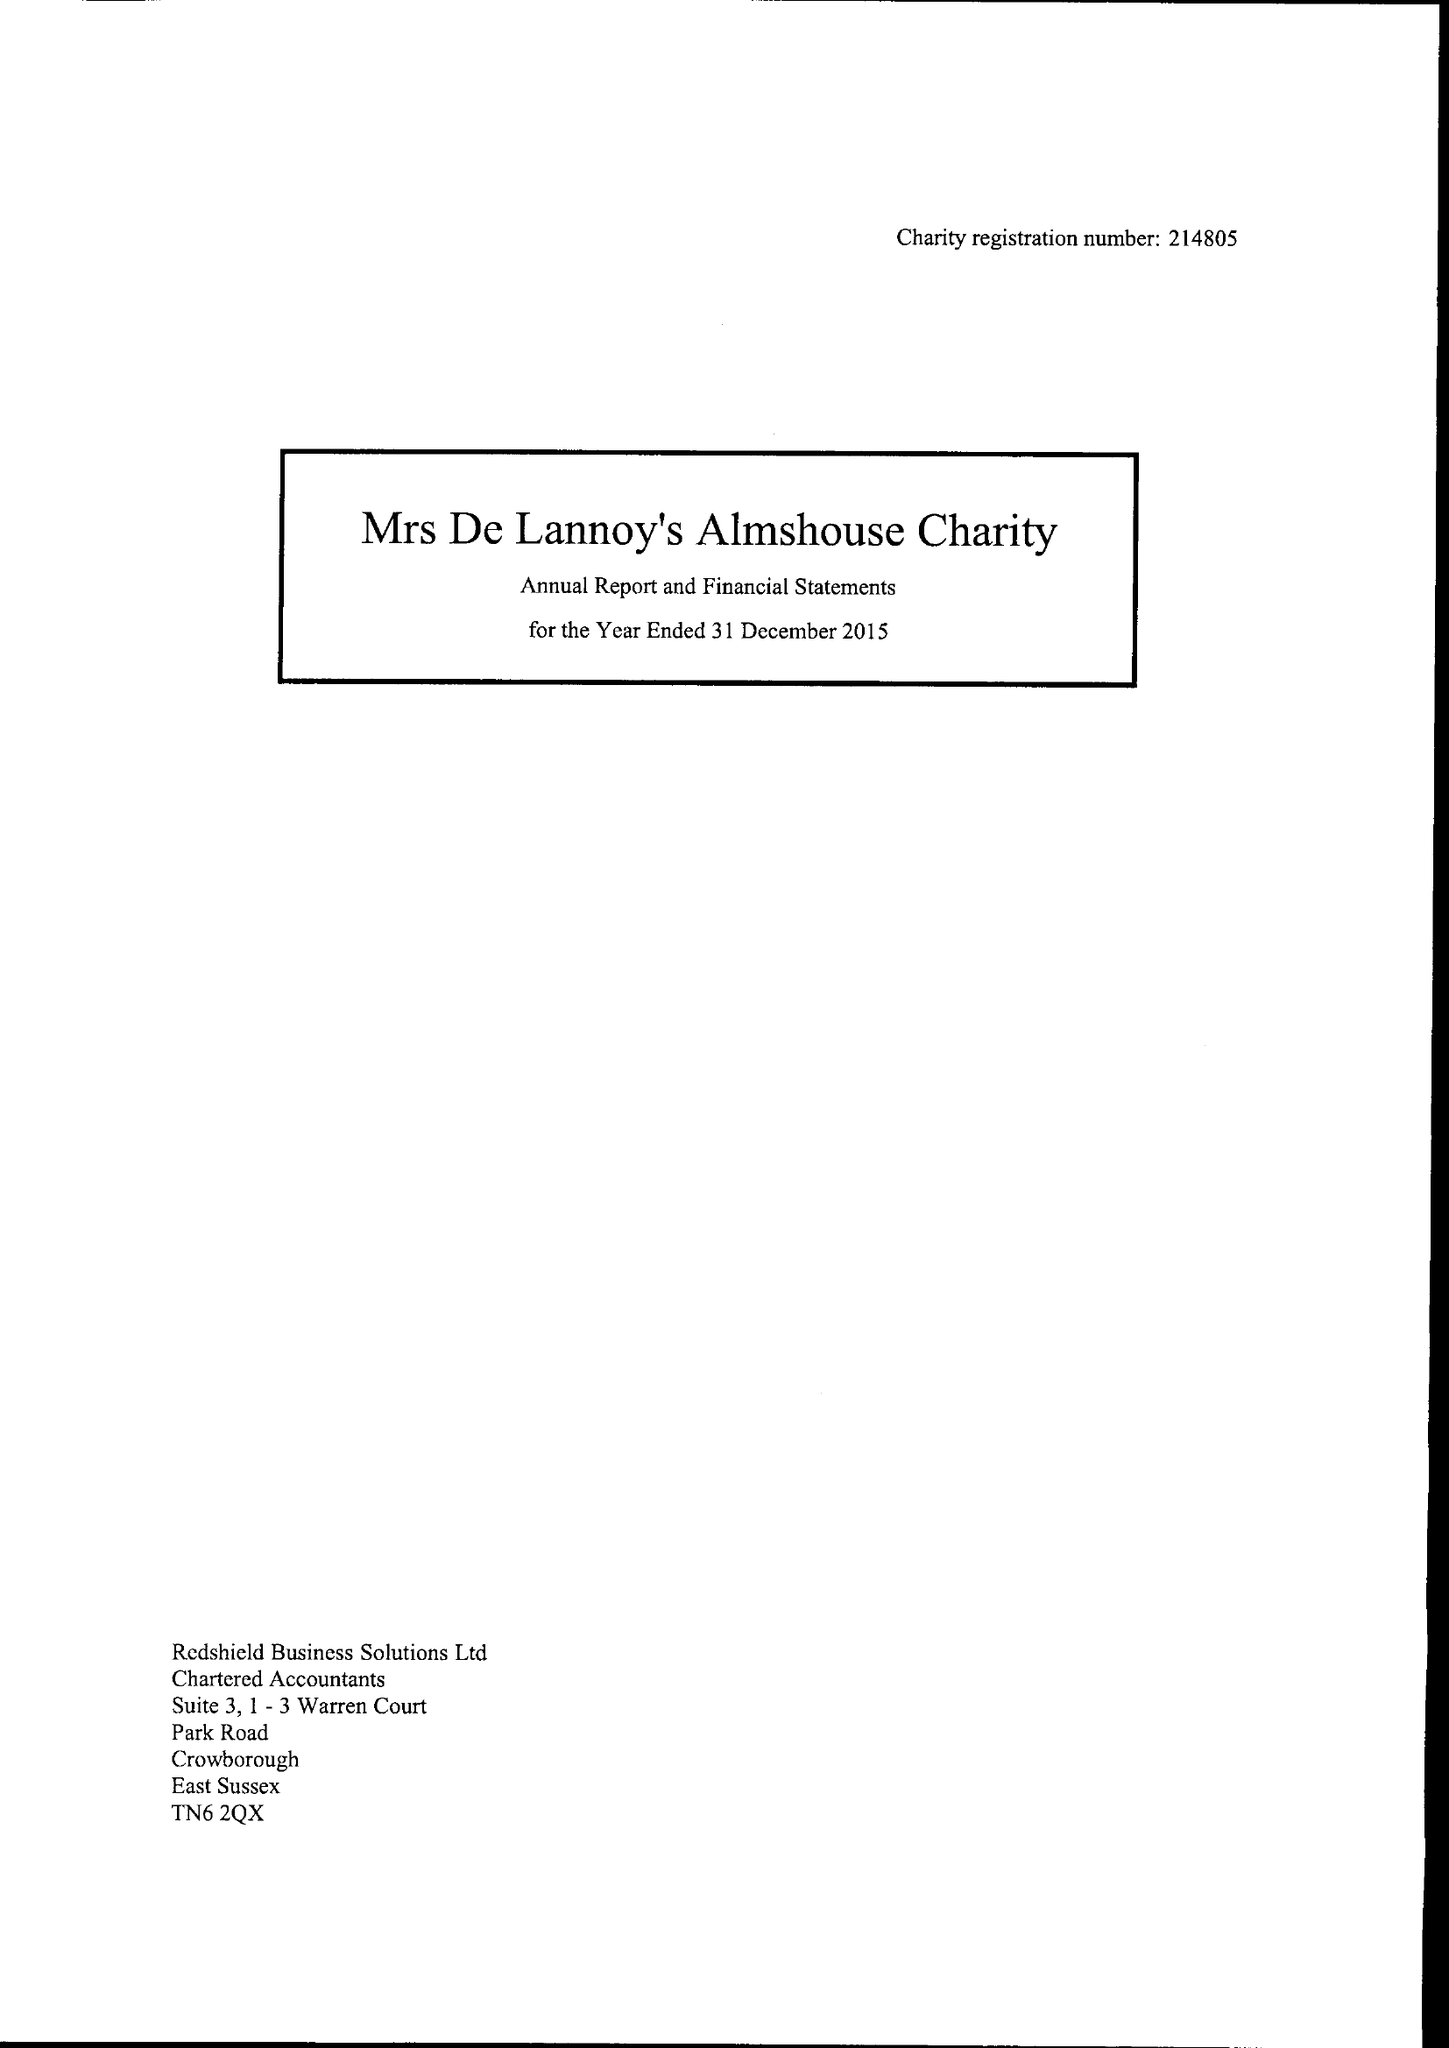What is the value for the spending_annually_in_british_pounds?
Answer the question using a single word or phrase. 41958.00 